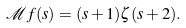<formula> <loc_0><loc_0><loc_500><loc_500>\mathcal { M } f ( s ) = ( s + 1 ) \zeta ( s + 2 ) .</formula> 